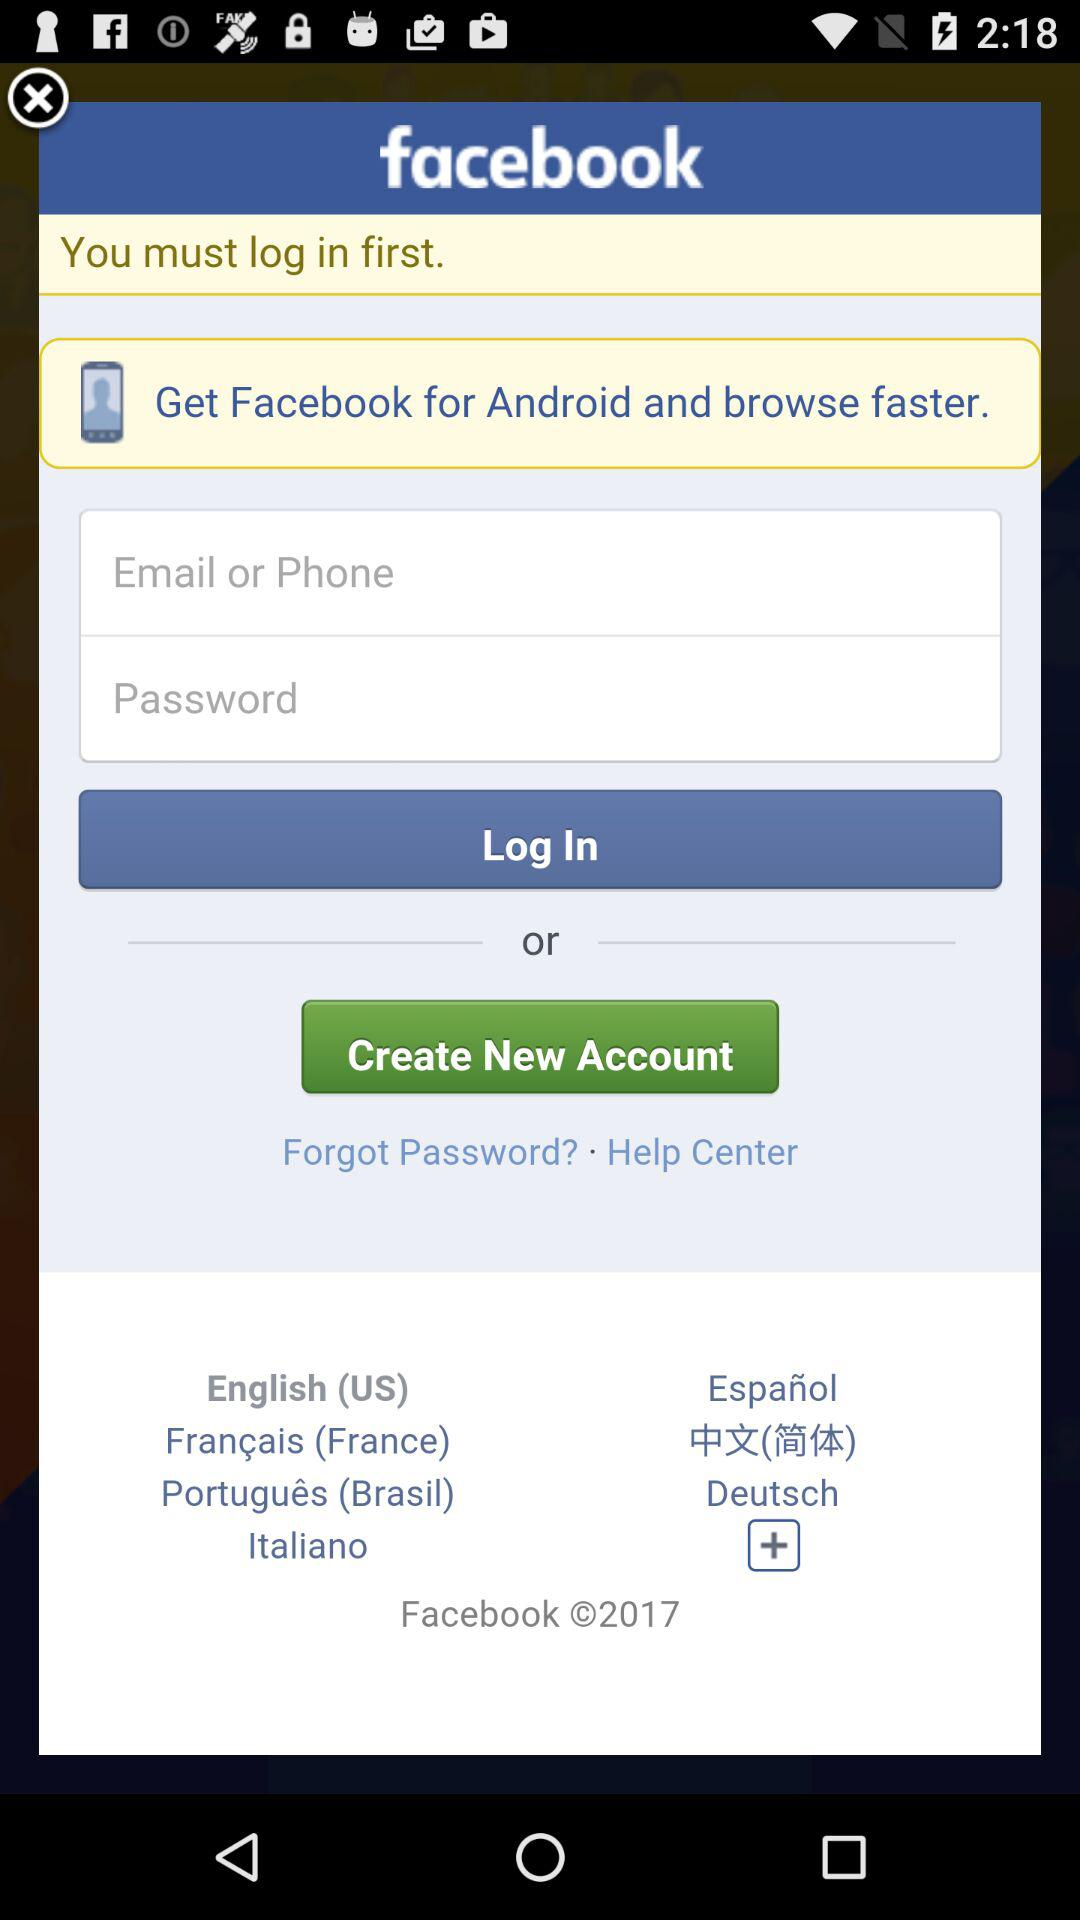How many text input fields are there in the login form?
Answer the question using a single word or phrase. 2 